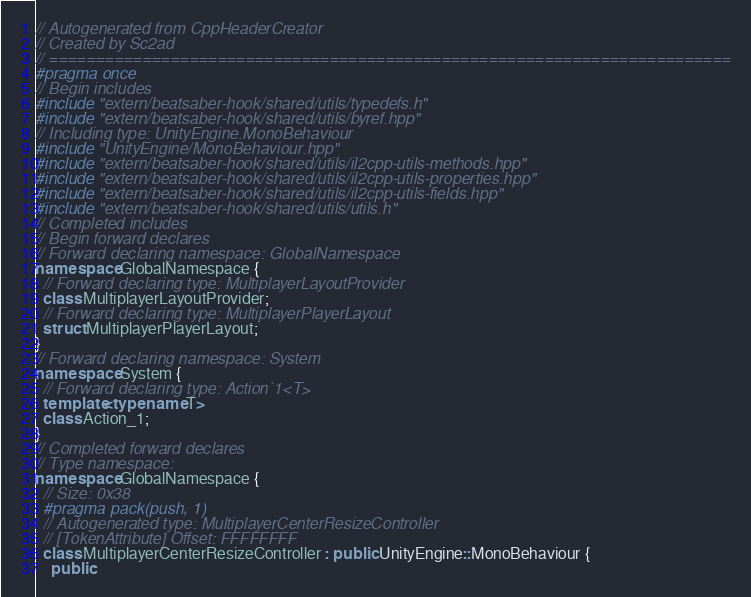<code> <loc_0><loc_0><loc_500><loc_500><_C++_>// Autogenerated from CppHeaderCreator
// Created by Sc2ad
// =========================================================================
#pragma once
// Begin includes
#include "extern/beatsaber-hook/shared/utils/typedefs.h"
#include "extern/beatsaber-hook/shared/utils/byref.hpp"
// Including type: UnityEngine.MonoBehaviour
#include "UnityEngine/MonoBehaviour.hpp"
#include "extern/beatsaber-hook/shared/utils/il2cpp-utils-methods.hpp"
#include "extern/beatsaber-hook/shared/utils/il2cpp-utils-properties.hpp"
#include "extern/beatsaber-hook/shared/utils/il2cpp-utils-fields.hpp"
#include "extern/beatsaber-hook/shared/utils/utils.h"
// Completed includes
// Begin forward declares
// Forward declaring namespace: GlobalNamespace
namespace GlobalNamespace {
  // Forward declaring type: MultiplayerLayoutProvider
  class MultiplayerLayoutProvider;
  // Forward declaring type: MultiplayerPlayerLayout
  struct MultiplayerPlayerLayout;
}
// Forward declaring namespace: System
namespace System {
  // Forward declaring type: Action`1<T>
  template<typename T>
  class Action_1;
}
// Completed forward declares
// Type namespace: 
namespace GlobalNamespace {
  // Size: 0x38
  #pragma pack(push, 1)
  // Autogenerated type: MultiplayerCenterResizeController
  // [TokenAttribute] Offset: FFFFFFFF
  class MultiplayerCenterResizeController : public UnityEngine::MonoBehaviour {
    public:</code> 